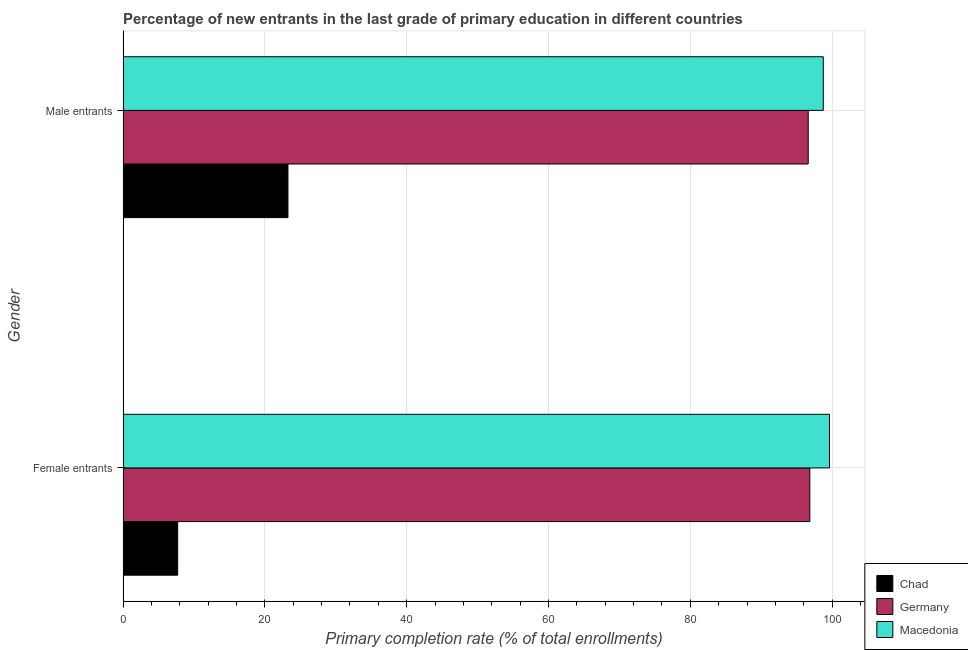Are the number of bars on each tick of the Y-axis equal?
Keep it short and to the point. Yes. How many bars are there on the 2nd tick from the top?
Give a very brief answer. 3. How many bars are there on the 2nd tick from the bottom?
Make the answer very short. 3. What is the label of the 1st group of bars from the top?
Your response must be concise. Male entrants. What is the primary completion rate of male entrants in Chad?
Your answer should be very brief. 23.26. Across all countries, what is the maximum primary completion rate of female entrants?
Offer a terse response. 99.62. Across all countries, what is the minimum primary completion rate of male entrants?
Ensure brevity in your answer.  23.26. In which country was the primary completion rate of female entrants maximum?
Your answer should be very brief. Macedonia. In which country was the primary completion rate of female entrants minimum?
Keep it short and to the point. Chad. What is the total primary completion rate of female entrants in the graph?
Your answer should be compact. 204.18. What is the difference between the primary completion rate of female entrants in Macedonia and that in Germany?
Keep it short and to the point. 2.77. What is the difference between the primary completion rate of male entrants in Germany and the primary completion rate of female entrants in Macedonia?
Offer a terse response. -3. What is the average primary completion rate of female entrants per country?
Make the answer very short. 68.06. What is the difference between the primary completion rate of male entrants and primary completion rate of female entrants in Germany?
Your answer should be very brief. -0.23. What is the ratio of the primary completion rate of male entrants in Germany to that in Chad?
Your answer should be very brief. 4.15. In how many countries, is the primary completion rate of male entrants greater than the average primary completion rate of male entrants taken over all countries?
Give a very brief answer. 2. What does the 3rd bar from the top in Male entrants represents?
Offer a very short reply. Chad. How many countries are there in the graph?
Provide a short and direct response. 3. Are the values on the major ticks of X-axis written in scientific E-notation?
Your response must be concise. No. Does the graph contain any zero values?
Provide a succinct answer. No. Does the graph contain grids?
Provide a short and direct response. Yes. How many legend labels are there?
Offer a very short reply. 3. What is the title of the graph?
Give a very brief answer. Percentage of new entrants in the last grade of primary education in different countries. Does "Kosovo" appear as one of the legend labels in the graph?
Your response must be concise. No. What is the label or title of the X-axis?
Give a very brief answer. Primary completion rate (% of total enrollments). What is the label or title of the Y-axis?
Ensure brevity in your answer.  Gender. What is the Primary completion rate (% of total enrollments) in Chad in Female entrants?
Provide a short and direct response. 7.71. What is the Primary completion rate (% of total enrollments) in Germany in Female entrants?
Provide a short and direct response. 96.85. What is the Primary completion rate (% of total enrollments) of Macedonia in Female entrants?
Offer a very short reply. 99.62. What is the Primary completion rate (% of total enrollments) of Chad in Male entrants?
Provide a short and direct response. 23.26. What is the Primary completion rate (% of total enrollments) of Germany in Male entrants?
Provide a succinct answer. 96.62. What is the Primary completion rate (% of total enrollments) in Macedonia in Male entrants?
Your answer should be very brief. 98.75. Across all Gender, what is the maximum Primary completion rate (% of total enrollments) of Chad?
Give a very brief answer. 23.26. Across all Gender, what is the maximum Primary completion rate (% of total enrollments) of Germany?
Give a very brief answer. 96.85. Across all Gender, what is the maximum Primary completion rate (% of total enrollments) of Macedonia?
Keep it short and to the point. 99.62. Across all Gender, what is the minimum Primary completion rate (% of total enrollments) of Chad?
Give a very brief answer. 7.71. Across all Gender, what is the minimum Primary completion rate (% of total enrollments) in Germany?
Your answer should be compact. 96.62. Across all Gender, what is the minimum Primary completion rate (% of total enrollments) in Macedonia?
Your answer should be very brief. 98.75. What is the total Primary completion rate (% of total enrollments) in Chad in the graph?
Ensure brevity in your answer.  30.97. What is the total Primary completion rate (% of total enrollments) in Germany in the graph?
Provide a short and direct response. 193.47. What is the total Primary completion rate (% of total enrollments) in Macedonia in the graph?
Give a very brief answer. 198.37. What is the difference between the Primary completion rate (% of total enrollments) in Chad in Female entrants and that in Male entrants?
Give a very brief answer. -15.55. What is the difference between the Primary completion rate (% of total enrollments) in Germany in Female entrants and that in Male entrants?
Offer a very short reply. 0.23. What is the difference between the Primary completion rate (% of total enrollments) of Macedonia in Female entrants and that in Male entrants?
Your answer should be very brief. 0.88. What is the difference between the Primary completion rate (% of total enrollments) in Chad in Female entrants and the Primary completion rate (% of total enrollments) in Germany in Male entrants?
Offer a very short reply. -88.91. What is the difference between the Primary completion rate (% of total enrollments) in Chad in Female entrants and the Primary completion rate (% of total enrollments) in Macedonia in Male entrants?
Your answer should be compact. -91.03. What is the difference between the Primary completion rate (% of total enrollments) of Germany in Female entrants and the Primary completion rate (% of total enrollments) of Macedonia in Male entrants?
Ensure brevity in your answer.  -1.9. What is the average Primary completion rate (% of total enrollments) in Chad per Gender?
Your answer should be compact. 15.49. What is the average Primary completion rate (% of total enrollments) in Germany per Gender?
Offer a very short reply. 96.73. What is the average Primary completion rate (% of total enrollments) of Macedonia per Gender?
Your answer should be compact. 99.18. What is the difference between the Primary completion rate (% of total enrollments) in Chad and Primary completion rate (% of total enrollments) in Germany in Female entrants?
Offer a very short reply. -89.14. What is the difference between the Primary completion rate (% of total enrollments) in Chad and Primary completion rate (% of total enrollments) in Macedonia in Female entrants?
Provide a succinct answer. -91.91. What is the difference between the Primary completion rate (% of total enrollments) in Germany and Primary completion rate (% of total enrollments) in Macedonia in Female entrants?
Offer a terse response. -2.77. What is the difference between the Primary completion rate (% of total enrollments) of Chad and Primary completion rate (% of total enrollments) of Germany in Male entrants?
Keep it short and to the point. -73.36. What is the difference between the Primary completion rate (% of total enrollments) of Chad and Primary completion rate (% of total enrollments) of Macedonia in Male entrants?
Offer a terse response. -75.49. What is the difference between the Primary completion rate (% of total enrollments) in Germany and Primary completion rate (% of total enrollments) in Macedonia in Male entrants?
Your response must be concise. -2.12. What is the ratio of the Primary completion rate (% of total enrollments) in Chad in Female entrants to that in Male entrants?
Your answer should be very brief. 0.33. What is the ratio of the Primary completion rate (% of total enrollments) of Germany in Female entrants to that in Male entrants?
Provide a short and direct response. 1. What is the ratio of the Primary completion rate (% of total enrollments) in Macedonia in Female entrants to that in Male entrants?
Make the answer very short. 1.01. What is the difference between the highest and the second highest Primary completion rate (% of total enrollments) in Chad?
Your response must be concise. 15.55. What is the difference between the highest and the second highest Primary completion rate (% of total enrollments) in Germany?
Your response must be concise. 0.23. What is the difference between the highest and the second highest Primary completion rate (% of total enrollments) in Macedonia?
Your answer should be compact. 0.88. What is the difference between the highest and the lowest Primary completion rate (% of total enrollments) of Chad?
Provide a succinct answer. 15.55. What is the difference between the highest and the lowest Primary completion rate (% of total enrollments) in Germany?
Keep it short and to the point. 0.23. What is the difference between the highest and the lowest Primary completion rate (% of total enrollments) in Macedonia?
Provide a succinct answer. 0.88. 